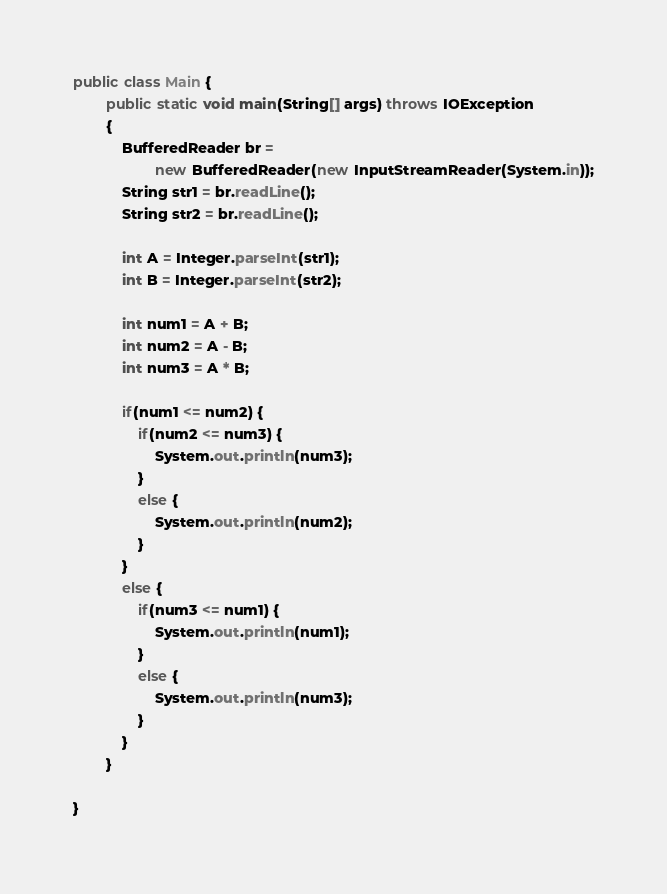<code> <loc_0><loc_0><loc_500><loc_500><_Java_>public class Main {
        public static void main(String[] args) throws IOException
        {
        	BufferedReader br = 
        			new BufferedReader(new InputStreamReader(System.in));
        	String str1 = br.readLine();
        	String str2 = br.readLine();
        	
        	int A = Integer.parseInt(str1);
        	int B = Integer.parseInt(str2);
        	
        	int num1 = A + B;
        	int num2 = A - B;
        	int num3 = A * B;
        	
        	if(num1 <= num2) {
        		if(num2 <= num3) {
        			System.out.println(num3);
        		} 
        		else {
        			System.out.println(num2);
        		}
        	}
        	else {
        		if(num3 <= num1) {
        			System.out.println(num1);
        		}
        		else {
        			System.out.println(num3);
        		}
        	}
        }
      
}
</code> 